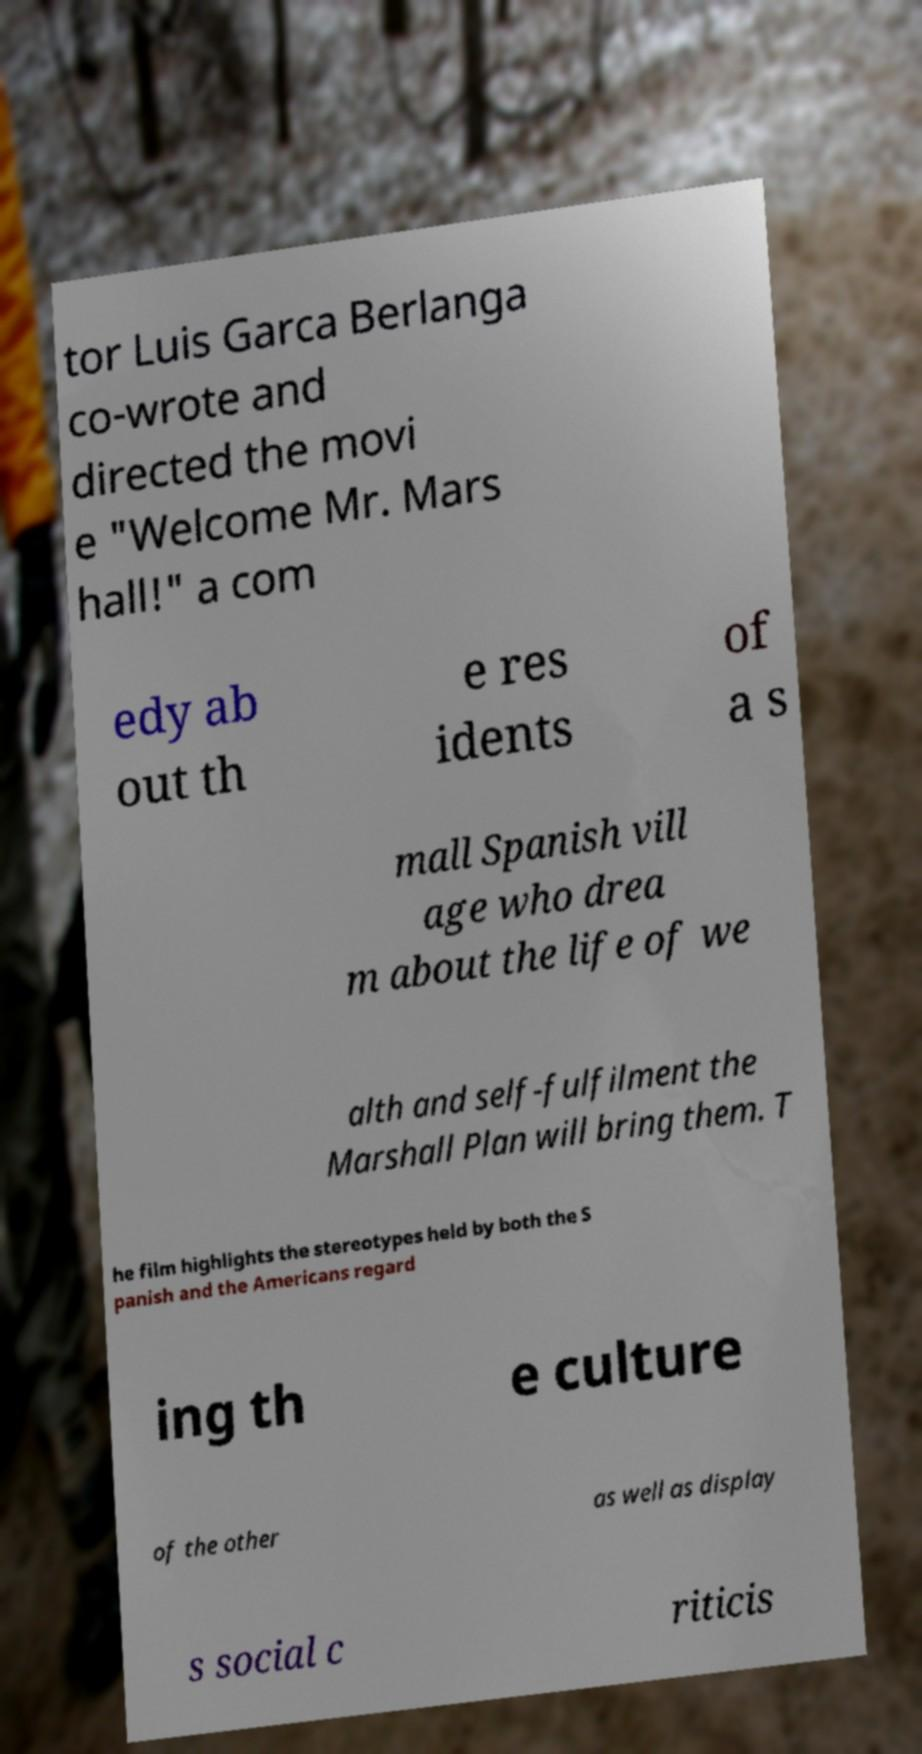There's text embedded in this image that I need extracted. Can you transcribe it verbatim? tor Luis Garca Berlanga co-wrote and directed the movi e "Welcome Mr. Mars hall!" a com edy ab out th e res idents of a s mall Spanish vill age who drea m about the life of we alth and self-fulfilment the Marshall Plan will bring them. T he film highlights the stereotypes held by both the S panish and the Americans regard ing th e culture of the other as well as display s social c riticis 